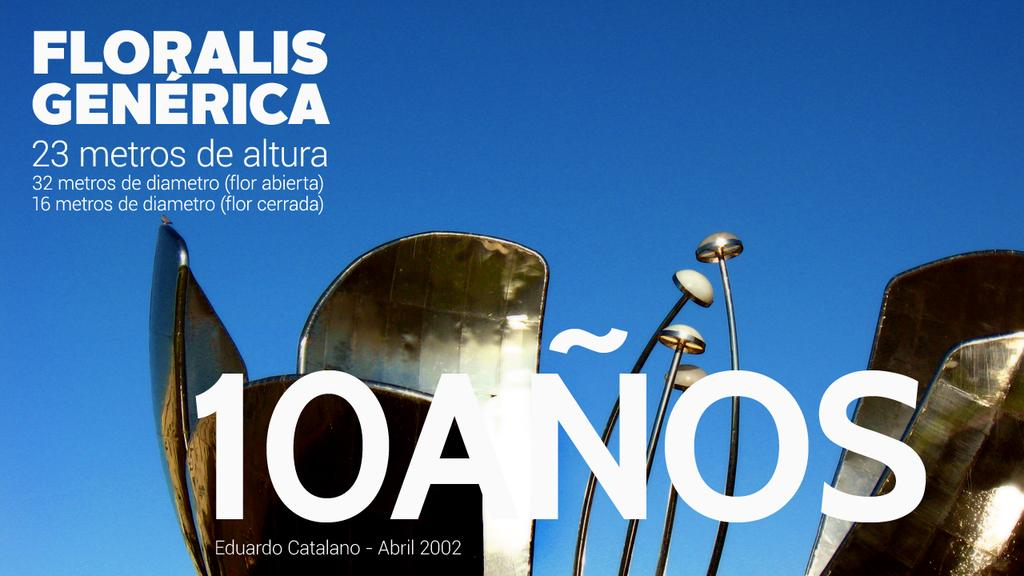What material is the poster made of in the image? The poster is a metal object. What shape does the metal object resemble? The metal object resembles a flower. What type of information is present on the poster? There are letters and numbers on the poster. What color is the background of the poster? The background of the poster is blue in color. Can you tell me how many judges are depicted on the poster? There are no judges depicted on the poster; it features a metal object resembling a flower with letters and numbers on it. What type of metal is the poster made of, such as copper? The facts provided do not specify the type of metal used for the poster, only that it is a metal object. 